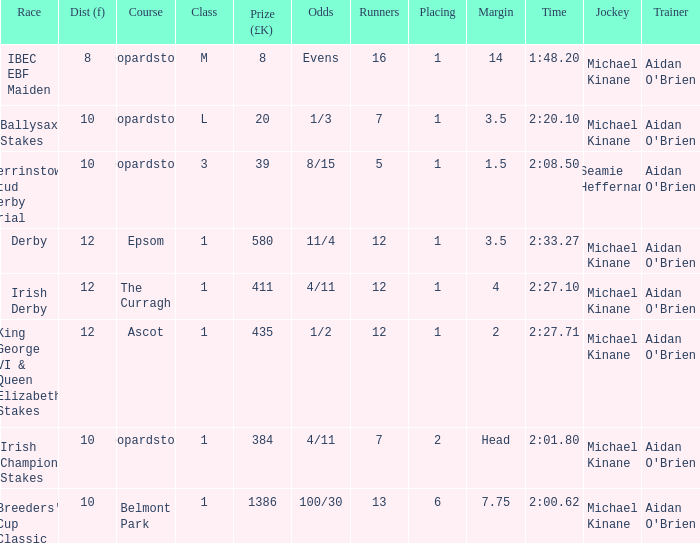Which category features a jockey of michael kinane with a time of 2:2 1.0. I'm looking to parse the entire table for insights. Could you assist me with that? {'header': ['Race', 'Dist (f)', 'Course', 'Class', 'Prize (£K)', 'Odds', 'Runners', 'Placing', 'Margin', 'Time', 'Jockey', 'Trainer'], 'rows': [['IBEC EBF Maiden', '8', 'Leopardstown', 'M', '8', 'Evens', '16', '1', '14', '1:48.20', 'Michael Kinane', "Aidan O'Brien"], ['Ballysax Stakes', '10', 'Leopardstown', 'L', '20', '1/3', '7', '1', '3.5', '2:20.10', 'Michael Kinane', "Aidan O'Brien"], ['Derrinstown Stud Derby Trial', '10', 'Leopardstown', '3', '39', '8/15', '5', '1', '1.5', '2:08.50', 'Seamie Heffernan', "Aidan O'Brien"], ['Derby', '12', 'Epsom', '1', '580', '11/4', '12', '1', '3.5', '2:33.27', 'Michael Kinane', "Aidan O'Brien"], ['Irish Derby', '12', 'The Curragh', '1', '411', '4/11', '12', '1', '4', '2:27.10', 'Michael Kinane', "Aidan O'Brien"], ['King George VI & Queen Elizabeth Stakes', '12', 'Ascot', '1', '435', '1/2', '12', '1', '2', '2:27.71', 'Michael Kinane', "Aidan O'Brien"], ['Irish Champion Stakes', '10', 'Leopardstown', '1', '384', '4/11', '7', '2', 'Head', '2:01.80', 'Michael Kinane', "Aidan O'Brien"], ["Breeders' Cup Classic", '10', 'Belmont Park', '1', '1386', '100/30', '13', '6', '7.75', '2:00.62', 'Michael Kinane', "Aidan O'Brien"]]} 